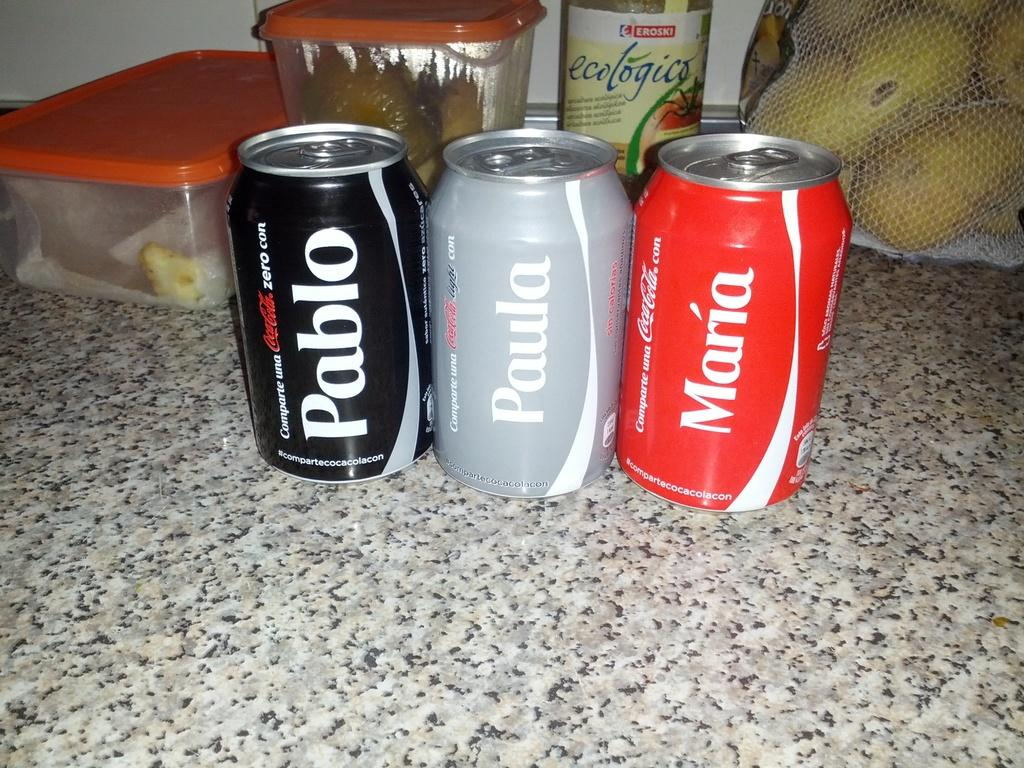<image>
Present a compact description of the photo's key features. Three personalized coke cans with the names Pablo, Monica and Paula printed on them. 